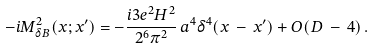<formula> <loc_0><loc_0><loc_500><loc_500>- i M ^ { 2 } _ { \delta B } ( x ; x ^ { \prime } ) = - \frac { i 3 e ^ { 2 } H ^ { 2 } } { 2 ^ { 6 } \pi ^ { 2 } } \, a ^ { 4 } \delta ^ { 4 } ( x \, - \, x ^ { \prime } ) + O ( D \, - \, 4 ) \, .</formula> 